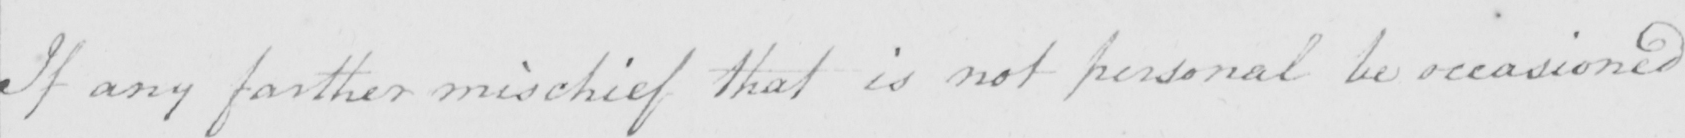Can you tell me what this handwritten text says? If any farther mischief that is not personal be occasioned 